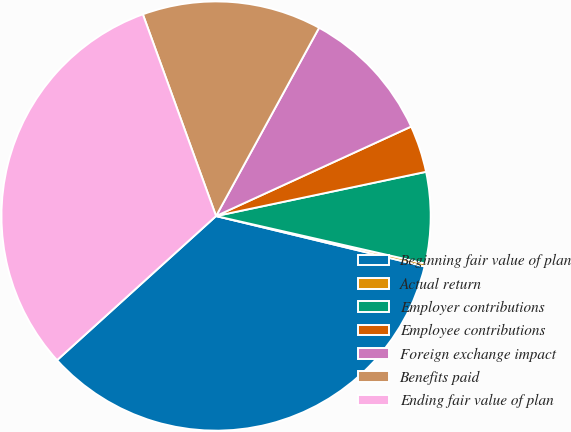Convert chart to OTSL. <chart><loc_0><loc_0><loc_500><loc_500><pie_chart><fcel>Beginning fair value of plan<fcel>Actual return<fcel>Employer contributions<fcel>Employee contributions<fcel>Foreign exchange impact<fcel>Benefits paid<fcel>Ending fair value of plan<nl><fcel>34.51%<fcel>0.22%<fcel>6.86%<fcel>3.54%<fcel>10.19%<fcel>13.51%<fcel>31.18%<nl></chart> 